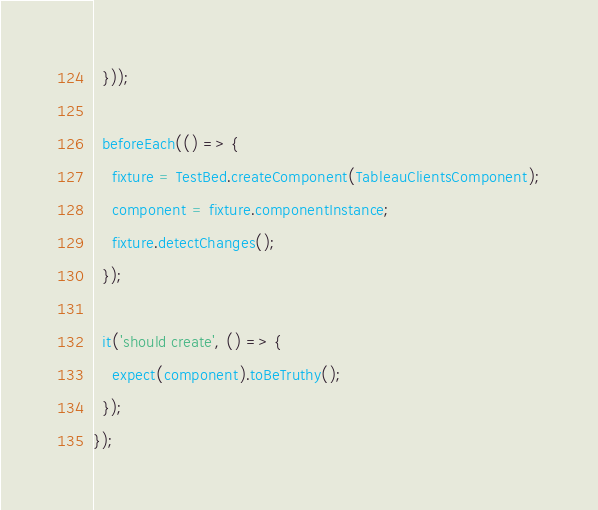<code> <loc_0><loc_0><loc_500><loc_500><_TypeScript_>  }));

  beforeEach(() => {
    fixture = TestBed.createComponent(TableauClientsComponent);
    component = fixture.componentInstance;
    fixture.detectChanges();
  });

  it('should create', () => {
    expect(component).toBeTruthy();
  });
});
</code> 